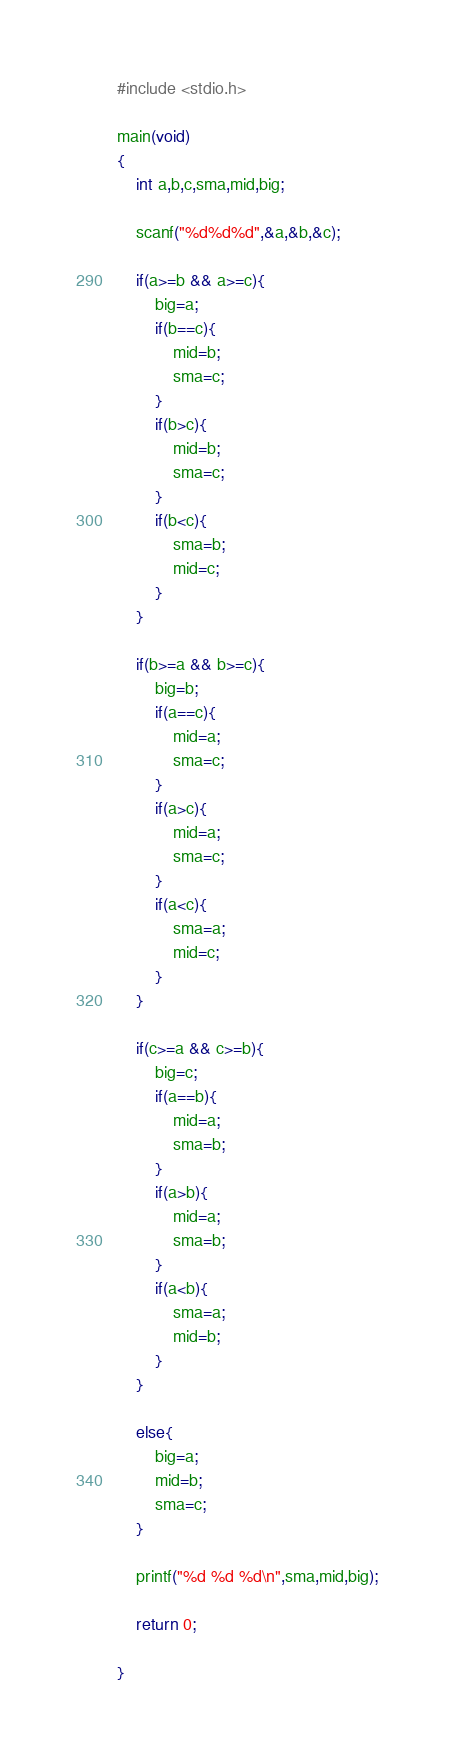<code> <loc_0><loc_0><loc_500><loc_500><_C_>#include <stdio.h>

main(void)
{
	int a,b,c,sma,mid,big;
	
	scanf("%d%d%d",&a,&b,&c);
	
	if(a>=b && a>=c){
		big=a;
		if(b==c){
			mid=b;
			sma=c;
		}
		if(b>c){
			mid=b;
			sma=c;
		}
		if(b<c){
			sma=b;
			mid=c;
		}
	}
	
	if(b>=a && b>=c){
		big=b;
		if(a==c){
			mid=a;
			sma=c;
		}
		if(a>c){
			mid=a;
			sma=c;
		}
		if(a<c){
			sma=a;
			mid=c;
		}
	}
	
	if(c>=a && c>=b){
		big=c;
		if(a==b){
			mid=a;
			sma=b;
		}
		if(a>b){
			mid=a;
			sma=b;
		}
		if(a<b){
			sma=a;
			mid=b;
		}
	}
	
	else{
		big=a;
		mid=b;
		sma=c;
	}
	
	printf("%d %d %d\n",sma,mid,big);
	
	return 0;
	
}</code> 